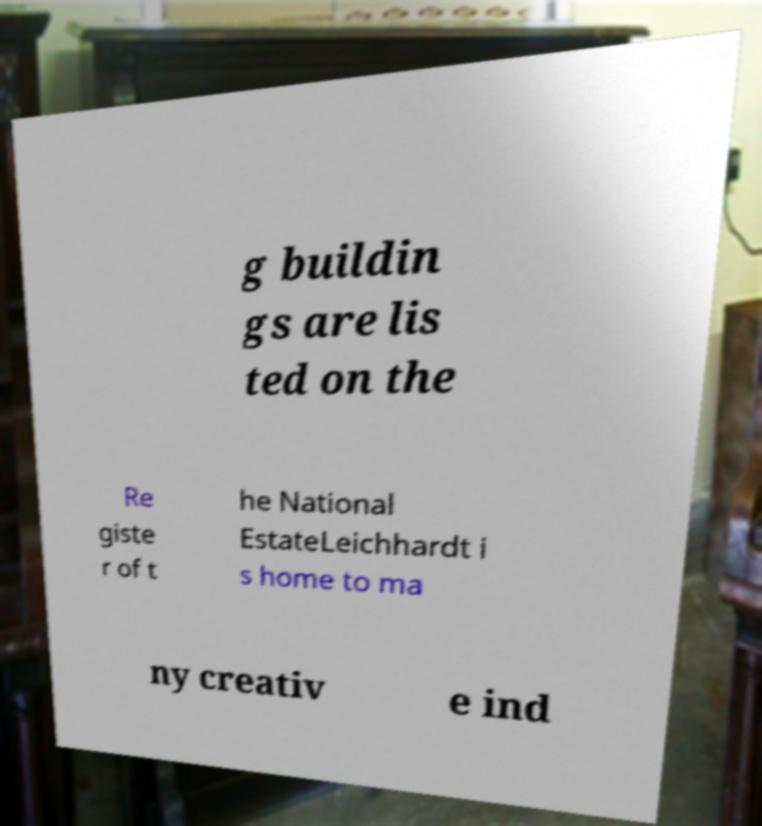Please identify and transcribe the text found in this image. g buildin gs are lis ted on the Re giste r of t he National EstateLeichhardt i s home to ma ny creativ e ind 